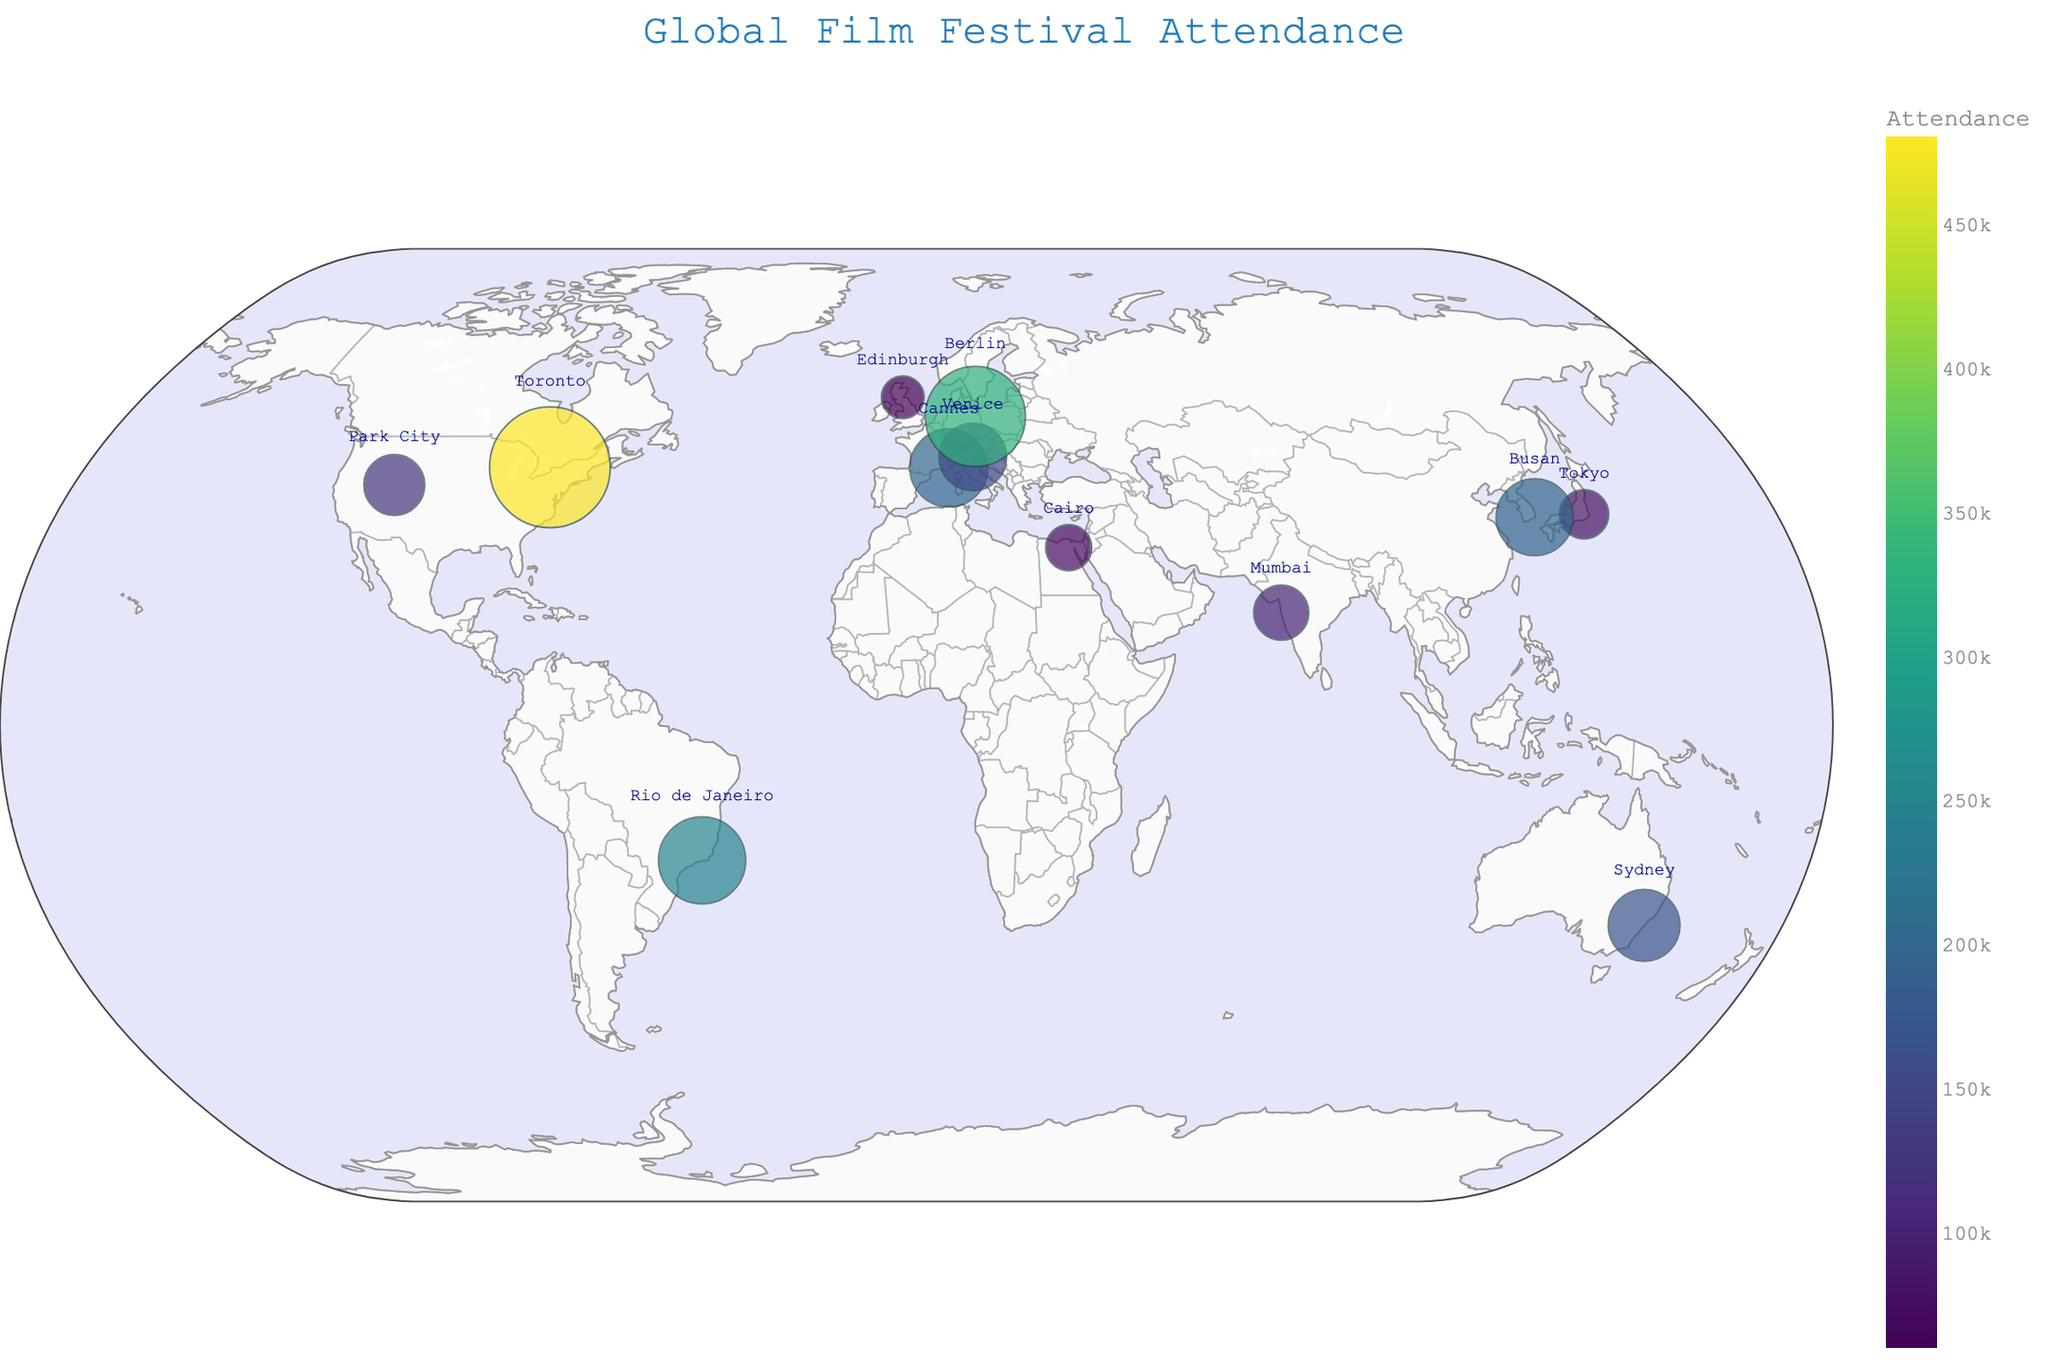What is the title of the figure? The title of a figure is typically located at the top and usually gives a brief idea of what the figure represents.
Answer: Global Film Festival Attendance Which film festival has the highest attendance? To find out the highest attendance, look for the largest circle on the map which represents the size of the attendance.
Answer: Toronto International Film Festival Which continents do not have any film festivals listed in the data? By observing the map, identify continents that do not have any circles (representing film festivals).
Answer: Africa (except for Egypt), Antarctica Arrange the film festivals in descending order of attendance. Sort the festivals based on the size of the circles from largest to smallest. From the data: Toronto, Cannes, Berlin, Rio de Janeiro, Venice, Busan, Sydney, Sundance, Mumbai, Tokyo, Cairo, Edinburgh.
Answer: Toronto, Cannes, Berlin, Rio de Janeiro, Venice, Busan, Sydney, Sundance, Mumbai, Tokyo, Cairo, Edinburgh Which film festivals are on the same continent? Group film festivals by the continent they are on (e.g. Europe, North America, Asia, etc.).
Answer: Cannes, Venice, Berlin, and Edinburgh are in Europe; Toronto and Sundance are in North America; Busan and Tokyo are in Asia; Sydney is in Australia; Cairo is in Africa; Rio de Janeiro is in South America What is the total attendance of all the film festivals combined? Sum up all the attendance figures from each film festival. From the data: 200000 + 122000 + 480000 + 150000 + 330000 + 80000 + 100000 + 170000 + 250000 + 70000 + 60000 + 195000 = 2,208,000.
Answer: 2,208,000 Which film festival in Asia has the lowest attendance? Look at the festivals located in Asia and compare their attendance figures. Tokyo and Busan are in Asia. Tokyo has 80,000 and Busan has 195,000. Tokyo has the lower attendance.
Answer: Tokyo International Film Festival How many film festivals in the figure have an attendance less than 100,000? Count the number of film festivals that have an attendance less than 100,000. From the data: Tokyo (80,000), Cairo (70,000), Edinburgh (60,000). One checks for any other such values.
Answer: Three What is the average attendance of the film festivals in Europe? Add up the attendance figures for the European film festivals and divide by the number of festivals: (200000 + 150000 + 330000 + 60000)/4, which simplifies to 740000/4 = 185000.
Answer: 185,000 Which film festival in the Americas has the second highest attendance? Compare the attendance figures of the festivals in North and South America: Toronto (480,000), Sundance (122,000), Rio de Janeiro (250,000). Rio de Janeiro has the second highest.
Answer: Rio de Janeiro International Film Festival 